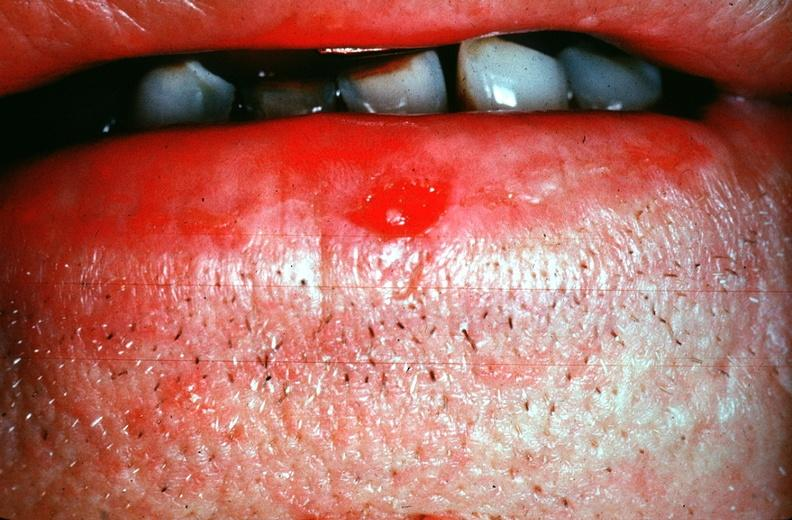does this image show squamous cell carcinoma, lip?
Answer the question using a single word or phrase. Yes 